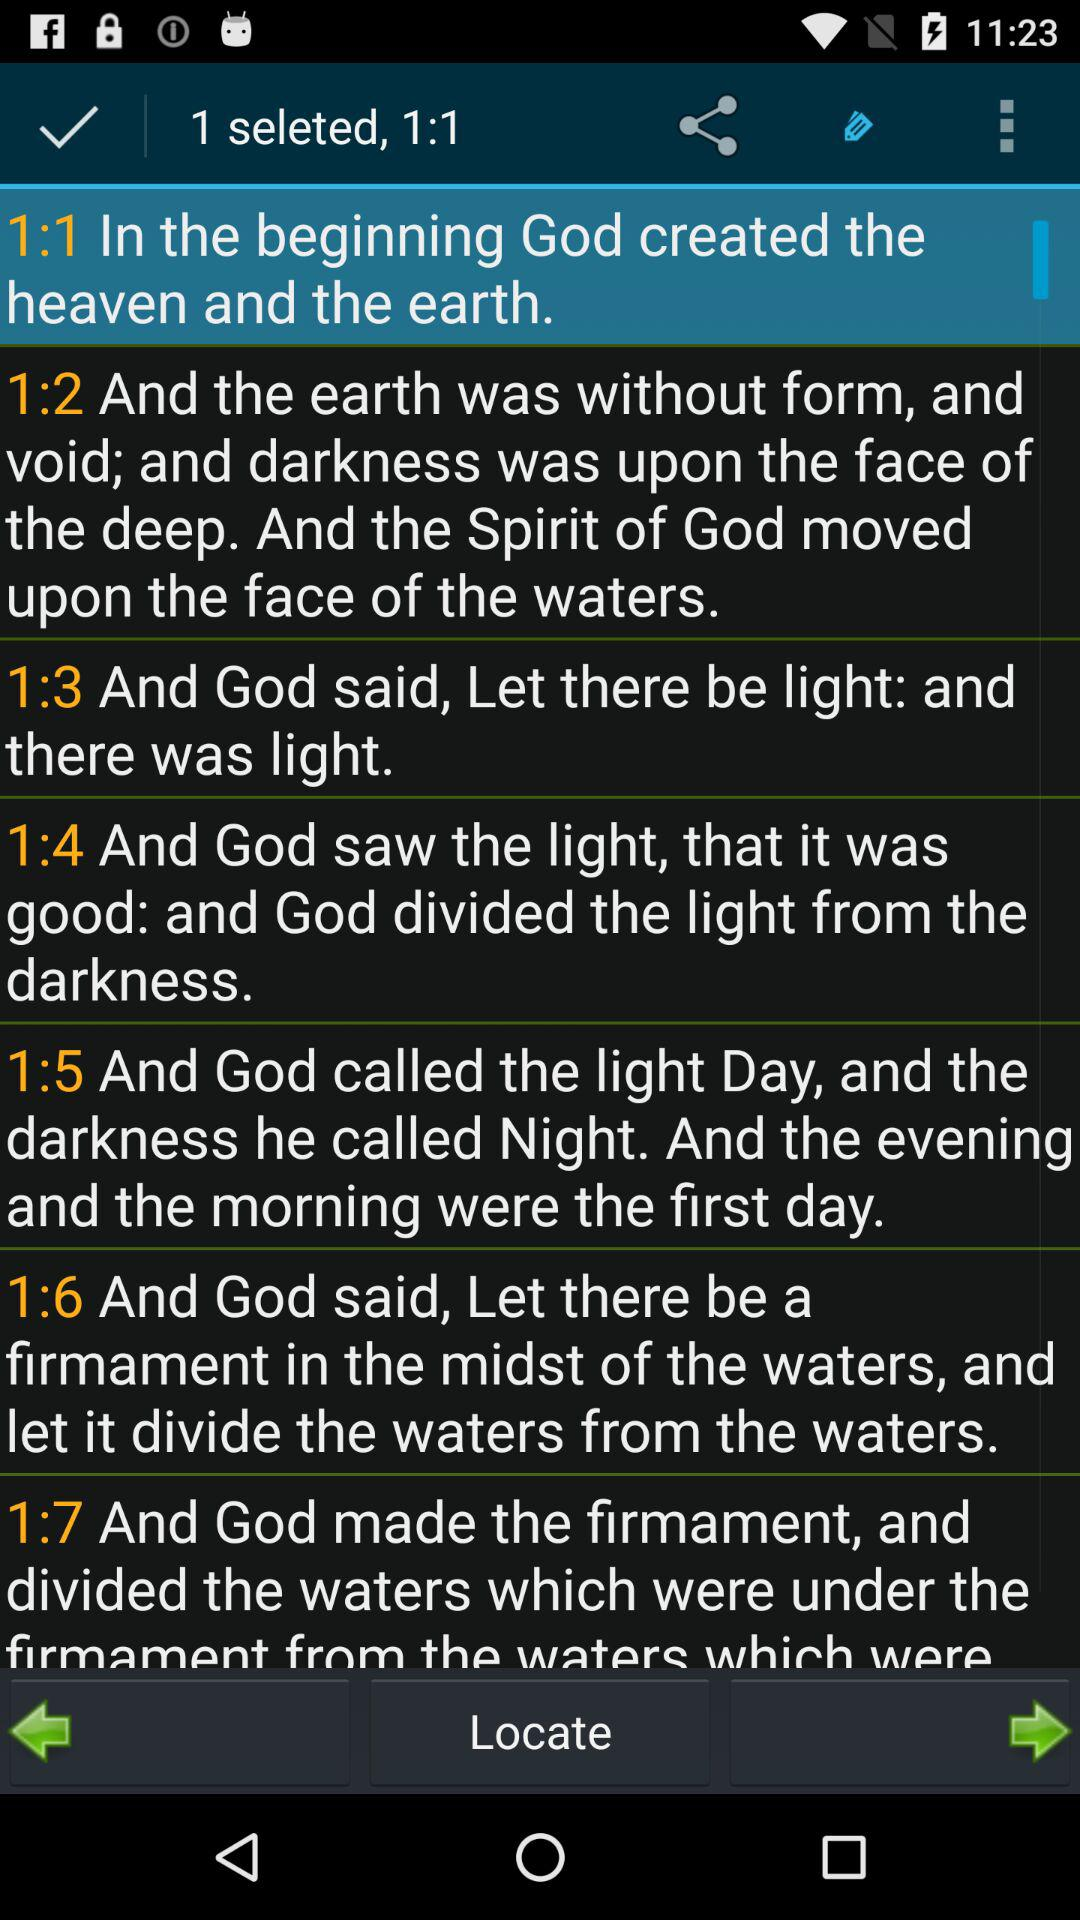How many items are selected?
Answer the question using a single word or phrase. 1 